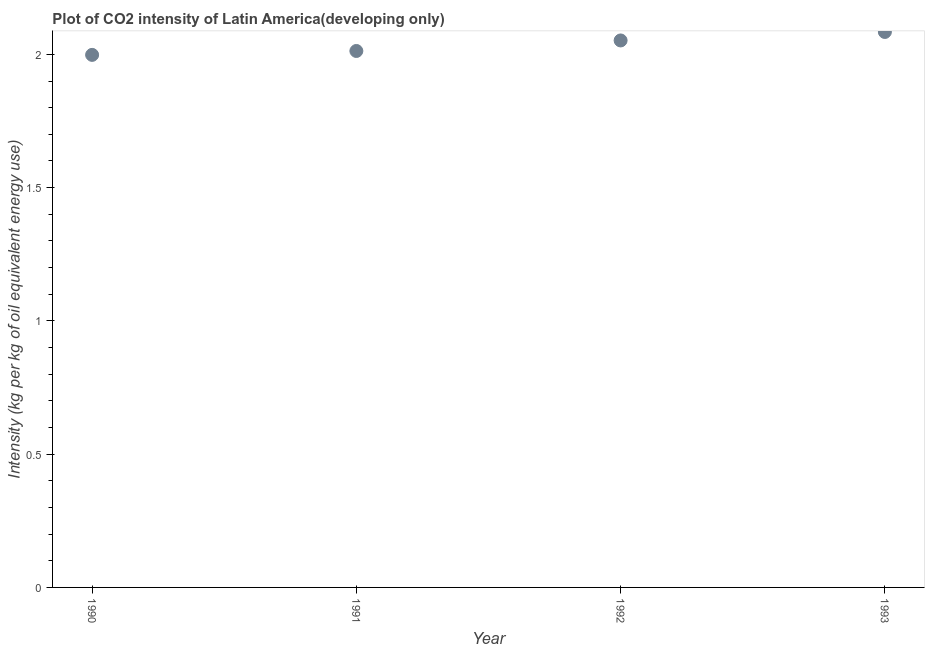What is the co2 intensity in 1990?
Keep it short and to the point. 2. Across all years, what is the maximum co2 intensity?
Provide a succinct answer. 2.08. Across all years, what is the minimum co2 intensity?
Provide a succinct answer. 2. In which year was the co2 intensity minimum?
Provide a short and direct response. 1990. What is the sum of the co2 intensity?
Make the answer very short. 8.15. What is the difference between the co2 intensity in 1991 and 1992?
Your answer should be compact. -0.04. What is the average co2 intensity per year?
Give a very brief answer. 2.04. What is the median co2 intensity?
Provide a short and direct response. 2.03. In how many years, is the co2 intensity greater than 1.5 kg?
Your response must be concise. 4. What is the ratio of the co2 intensity in 1990 to that in 1991?
Make the answer very short. 0.99. What is the difference between the highest and the second highest co2 intensity?
Offer a terse response. 0.03. Is the sum of the co2 intensity in 1992 and 1993 greater than the maximum co2 intensity across all years?
Give a very brief answer. Yes. What is the difference between the highest and the lowest co2 intensity?
Keep it short and to the point. 0.09. How many dotlines are there?
Give a very brief answer. 1. How many years are there in the graph?
Ensure brevity in your answer.  4. What is the difference between two consecutive major ticks on the Y-axis?
Offer a very short reply. 0.5. Does the graph contain any zero values?
Make the answer very short. No. Does the graph contain grids?
Your answer should be compact. No. What is the title of the graph?
Give a very brief answer. Plot of CO2 intensity of Latin America(developing only). What is the label or title of the X-axis?
Give a very brief answer. Year. What is the label or title of the Y-axis?
Give a very brief answer. Intensity (kg per kg of oil equivalent energy use). What is the Intensity (kg per kg of oil equivalent energy use) in 1990?
Your answer should be compact. 2. What is the Intensity (kg per kg of oil equivalent energy use) in 1991?
Make the answer very short. 2.01. What is the Intensity (kg per kg of oil equivalent energy use) in 1992?
Keep it short and to the point. 2.05. What is the Intensity (kg per kg of oil equivalent energy use) in 1993?
Offer a very short reply. 2.08. What is the difference between the Intensity (kg per kg of oil equivalent energy use) in 1990 and 1991?
Provide a succinct answer. -0.01. What is the difference between the Intensity (kg per kg of oil equivalent energy use) in 1990 and 1992?
Offer a very short reply. -0.05. What is the difference between the Intensity (kg per kg of oil equivalent energy use) in 1990 and 1993?
Offer a terse response. -0.09. What is the difference between the Intensity (kg per kg of oil equivalent energy use) in 1991 and 1992?
Ensure brevity in your answer.  -0.04. What is the difference between the Intensity (kg per kg of oil equivalent energy use) in 1991 and 1993?
Your answer should be very brief. -0.07. What is the difference between the Intensity (kg per kg of oil equivalent energy use) in 1992 and 1993?
Your answer should be compact. -0.03. What is the ratio of the Intensity (kg per kg of oil equivalent energy use) in 1990 to that in 1992?
Your answer should be very brief. 0.97. What is the ratio of the Intensity (kg per kg of oil equivalent energy use) in 1991 to that in 1992?
Offer a terse response. 0.98. What is the ratio of the Intensity (kg per kg of oil equivalent energy use) in 1992 to that in 1993?
Your answer should be compact. 0.98. 